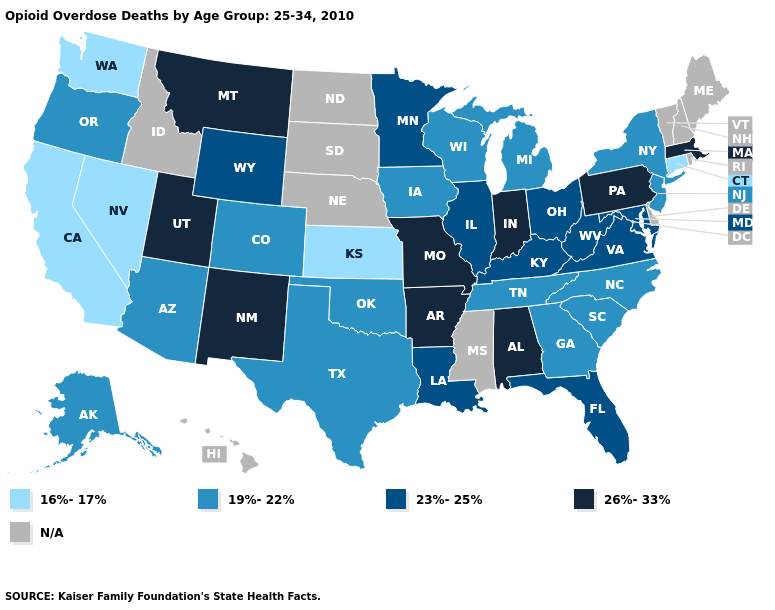Which states have the lowest value in the Northeast?
Quick response, please. Connecticut. Is the legend a continuous bar?
Short answer required. No. What is the value of North Dakota?
Write a very short answer. N/A. Which states have the highest value in the USA?
Quick response, please. Alabama, Arkansas, Indiana, Massachusetts, Missouri, Montana, New Mexico, Pennsylvania, Utah. What is the highest value in the USA?
Short answer required. 26%-33%. What is the value of Illinois?
Give a very brief answer. 23%-25%. Name the states that have a value in the range 26%-33%?
Write a very short answer. Alabama, Arkansas, Indiana, Massachusetts, Missouri, Montana, New Mexico, Pennsylvania, Utah. Name the states that have a value in the range 19%-22%?
Keep it brief. Alaska, Arizona, Colorado, Georgia, Iowa, Michigan, New Jersey, New York, North Carolina, Oklahoma, Oregon, South Carolina, Tennessee, Texas, Wisconsin. Name the states that have a value in the range 26%-33%?
Give a very brief answer. Alabama, Arkansas, Indiana, Massachusetts, Missouri, Montana, New Mexico, Pennsylvania, Utah. Does California have the lowest value in the USA?
Concise answer only. Yes. What is the value of Missouri?
Keep it brief. 26%-33%. What is the lowest value in states that border Texas?
Concise answer only. 19%-22%. What is the highest value in the Northeast ?
Be succinct. 26%-33%. 